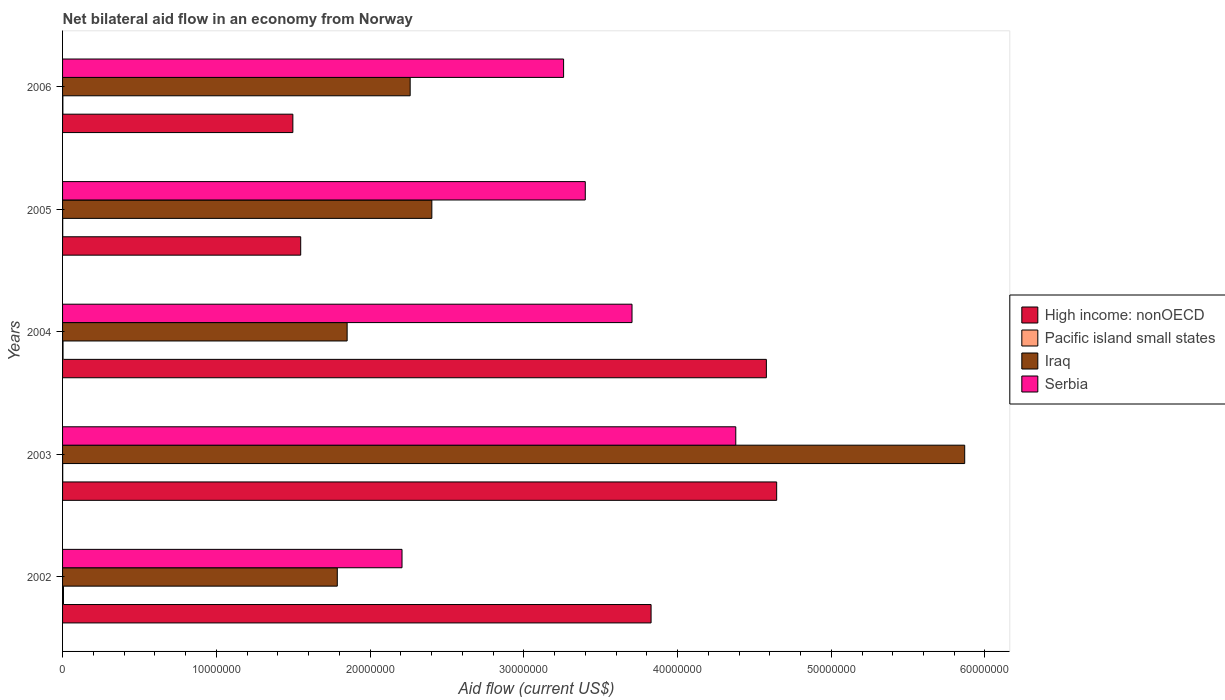How many different coloured bars are there?
Offer a terse response. 4. Are the number of bars per tick equal to the number of legend labels?
Your answer should be very brief. Yes. Are the number of bars on each tick of the Y-axis equal?
Keep it short and to the point. Yes. In how many cases, is the number of bars for a given year not equal to the number of legend labels?
Your answer should be compact. 0. What is the net bilateral aid flow in Serbia in 2002?
Give a very brief answer. 2.21e+07. Across all years, what is the maximum net bilateral aid flow in Pacific island small states?
Provide a succinct answer. 6.00e+04. Across all years, what is the minimum net bilateral aid flow in High income: nonOECD?
Your answer should be very brief. 1.50e+07. In which year was the net bilateral aid flow in High income: nonOECD maximum?
Provide a short and direct response. 2003. What is the total net bilateral aid flow in Serbia in the graph?
Ensure brevity in your answer.  1.70e+08. What is the difference between the net bilateral aid flow in Serbia in 2006 and the net bilateral aid flow in Pacific island small states in 2002?
Your answer should be very brief. 3.25e+07. What is the average net bilateral aid flow in Serbia per year?
Provide a succinct answer. 3.39e+07. In the year 2006, what is the difference between the net bilateral aid flow in High income: nonOECD and net bilateral aid flow in Serbia?
Your answer should be compact. -1.76e+07. What is the ratio of the net bilateral aid flow in High income: nonOECD in 2002 to that in 2003?
Your answer should be compact. 0.82. Is the difference between the net bilateral aid flow in High income: nonOECD in 2005 and 2006 greater than the difference between the net bilateral aid flow in Serbia in 2005 and 2006?
Offer a terse response. No. What is the difference between the highest and the second highest net bilateral aid flow in Iraq?
Keep it short and to the point. 3.47e+07. What is the difference between the highest and the lowest net bilateral aid flow in Iraq?
Offer a very short reply. 4.08e+07. What does the 1st bar from the top in 2003 represents?
Your answer should be compact. Serbia. What does the 3rd bar from the bottom in 2006 represents?
Your answer should be compact. Iraq. How many bars are there?
Provide a short and direct response. 20. Are all the bars in the graph horizontal?
Keep it short and to the point. Yes. What is the difference between two consecutive major ticks on the X-axis?
Your answer should be compact. 1.00e+07. Does the graph contain grids?
Your answer should be compact. No. How many legend labels are there?
Keep it short and to the point. 4. What is the title of the graph?
Your response must be concise. Net bilateral aid flow in an economy from Norway. What is the Aid flow (current US$) of High income: nonOECD in 2002?
Offer a terse response. 3.83e+07. What is the Aid flow (current US$) in Pacific island small states in 2002?
Provide a short and direct response. 6.00e+04. What is the Aid flow (current US$) of Iraq in 2002?
Make the answer very short. 1.79e+07. What is the Aid flow (current US$) in Serbia in 2002?
Keep it short and to the point. 2.21e+07. What is the Aid flow (current US$) in High income: nonOECD in 2003?
Provide a short and direct response. 4.64e+07. What is the Aid flow (current US$) of Pacific island small states in 2003?
Offer a terse response. 10000. What is the Aid flow (current US$) in Iraq in 2003?
Provide a succinct answer. 5.87e+07. What is the Aid flow (current US$) in Serbia in 2003?
Your response must be concise. 4.38e+07. What is the Aid flow (current US$) of High income: nonOECD in 2004?
Provide a succinct answer. 4.58e+07. What is the Aid flow (current US$) of Pacific island small states in 2004?
Make the answer very short. 3.00e+04. What is the Aid flow (current US$) in Iraq in 2004?
Offer a terse response. 1.85e+07. What is the Aid flow (current US$) in Serbia in 2004?
Keep it short and to the point. 3.70e+07. What is the Aid flow (current US$) of High income: nonOECD in 2005?
Make the answer very short. 1.55e+07. What is the Aid flow (current US$) in Pacific island small states in 2005?
Your response must be concise. 10000. What is the Aid flow (current US$) in Iraq in 2005?
Offer a terse response. 2.40e+07. What is the Aid flow (current US$) in Serbia in 2005?
Your response must be concise. 3.40e+07. What is the Aid flow (current US$) in High income: nonOECD in 2006?
Give a very brief answer. 1.50e+07. What is the Aid flow (current US$) of Pacific island small states in 2006?
Ensure brevity in your answer.  2.00e+04. What is the Aid flow (current US$) in Iraq in 2006?
Keep it short and to the point. 2.26e+07. What is the Aid flow (current US$) in Serbia in 2006?
Make the answer very short. 3.26e+07. Across all years, what is the maximum Aid flow (current US$) of High income: nonOECD?
Give a very brief answer. 4.64e+07. Across all years, what is the maximum Aid flow (current US$) of Pacific island small states?
Your answer should be very brief. 6.00e+04. Across all years, what is the maximum Aid flow (current US$) in Iraq?
Your answer should be compact. 5.87e+07. Across all years, what is the maximum Aid flow (current US$) in Serbia?
Give a very brief answer. 4.38e+07. Across all years, what is the minimum Aid flow (current US$) in High income: nonOECD?
Provide a succinct answer. 1.50e+07. Across all years, what is the minimum Aid flow (current US$) in Iraq?
Ensure brevity in your answer.  1.79e+07. Across all years, what is the minimum Aid flow (current US$) of Serbia?
Ensure brevity in your answer.  2.21e+07. What is the total Aid flow (current US$) of High income: nonOECD in the graph?
Keep it short and to the point. 1.61e+08. What is the total Aid flow (current US$) of Pacific island small states in the graph?
Ensure brevity in your answer.  1.30e+05. What is the total Aid flow (current US$) in Iraq in the graph?
Keep it short and to the point. 1.42e+08. What is the total Aid flow (current US$) in Serbia in the graph?
Ensure brevity in your answer.  1.70e+08. What is the difference between the Aid flow (current US$) in High income: nonOECD in 2002 and that in 2003?
Provide a succinct answer. -8.17e+06. What is the difference between the Aid flow (current US$) of Pacific island small states in 2002 and that in 2003?
Keep it short and to the point. 5.00e+04. What is the difference between the Aid flow (current US$) in Iraq in 2002 and that in 2003?
Your response must be concise. -4.08e+07. What is the difference between the Aid flow (current US$) in Serbia in 2002 and that in 2003?
Ensure brevity in your answer.  -2.17e+07. What is the difference between the Aid flow (current US$) in High income: nonOECD in 2002 and that in 2004?
Give a very brief answer. -7.50e+06. What is the difference between the Aid flow (current US$) in Iraq in 2002 and that in 2004?
Provide a succinct answer. -6.40e+05. What is the difference between the Aid flow (current US$) in Serbia in 2002 and that in 2004?
Your answer should be compact. -1.50e+07. What is the difference between the Aid flow (current US$) in High income: nonOECD in 2002 and that in 2005?
Your answer should be very brief. 2.28e+07. What is the difference between the Aid flow (current US$) in Iraq in 2002 and that in 2005?
Your answer should be compact. -6.15e+06. What is the difference between the Aid flow (current US$) of Serbia in 2002 and that in 2005?
Make the answer very short. -1.19e+07. What is the difference between the Aid flow (current US$) in High income: nonOECD in 2002 and that in 2006?
Keep it short and to the point. 2.33e+07. What is the difference between the Aid flow (current US$) in Iraq in 2002 and that in 2006?
Your answer should be very brief. -4.74e+06. What is the difference between the Aid flow (current US$) of Serbia in 2002 and that in 2006?
Your answer should be very brief. -1.05e+07. What is the difference between the Aid flow (current US$) of High income: nonOECD in 2003 and that in 2004?
Provide a short and direct response. 6.70e+05. What is the difference between the Aid flow (current US$) in Iraq in 2003 and that in 2004?
Offer a very short reply. 4.02e+07. What is the difference between the Aid flow (current US$) in Serbia in 2003 and that in 2004?
Provide a short and direct response. 6.75e+06. What is the difference between the Aid flow (current US$) in High income: nonOECD in 2003 and that in 2005?
Your response must be concise. 3.10e+07. What is the difference between the Aid flow (current US$) in Iraq in 2003 and that in 2005?
Provide a short and direct response. 3.47e+07. What is the difference between the Aid flow (current US$) of Serbia in 2003 and that in 2005?
Provide a short and direct response. 9.79e+06. What is the difference between the Aid flow (current US$) in High income: nonOECD in 2003 and that in 2006?
Make the answer very short. 3.15e+07. What is the difference between the Aid flow (current US$) of Pacific island small states in 2003 and that in 2006?
Make the answer very short. -10000. What is the difference between the Aid flow (current US$) of Iraq in 2003 and that in 2006?
Make the answer very short. 3.61e+07. What is the difference between the Aid flow (current US$) of Serbia in 2003 and that in 2006?
Your answer should be compact. 1.12e+07. What is the difference between the Aid flow (current US$) of High income: nonOECD in 2004 and that in 2005?
Your answer should be very brief. 3.03e+07. What is the difference between the Aid flow (current US$) of Pacific island small states in 2004 and that in 2005?
Your answer should be very brief. 2.00e+04. What is the difference between the Aid flow (current US$) in Iraq in 2004 and that in 2005?
Your response must be concise. -5.51e+06. What is the difference between the Aid flow (current US$) of Serbia in 2004 and that in 2005?
Keep it short and to the point. 3.04e+06. What is the difference between the Aid flow (current US$) in High income: nonOECD in 2004 and that in 2006?
Your response must be concise. 3.08e+07. What is the difference between the Aid flow (current US$) in Iraq in 2004 and that in 2006?
Your response must be concise. -4.10e+06. What is the difference between the Aid flow (current US$) in Serbia in 2004 and that in 2006?
Your response must be concise. 4.45e+06. What is the difference between the Aid flow (current US$) in High income: nonOECD in 2005 and that in 2006?
Ensure brevity in your answer.  5.10e+05. What is the difference between the Aid flow (current US$) of Pacific island small states in 2005 and that in 2006?
Your answer should be compact. -10000. What is the difference between the Aid flow (current US$) in Iraq in 2005 and that in 2006?
Provide a succinct answer. 1.41e+06. What is the difference between the Aid flow (current US$) of Serbia in 2005 and that in 2006?
Your answer should be compact. 1.41e+06. What is the difference between the Aid flow (current US$) of High income: nonOECD in 2002 and the Aid flow (current US$) of Pacific island small states in 2003?
Ensure brevity in your answer.  3.83e+07. What is the difference between the Aid flow (current US$) of High income: nonOECD in 2002 and the Aid flow (current US$) of Iraq in 2003?
Your answer should be very brief. -2.04e+07. What is the difference between the Aid flow (current US$) in High income: nonOECD in 2002 and the Aid flow (current US$) in Serbia in 2003?
Your answer should be very brief. -5.51e+06. What is the difference between the Aid flow (current US$) of Pacific island small states in 2002 and the Aid flow (current US$) of Iraq in 2003?
Provide a succinct answer. -5.86e+07. What is the difference between the Aid flow (current US$) in Pacific island small states in 2002 and the Aid flow (current US$) in Serbia in 2003?
Give a very brief answer. -4.37e+07. What is the difference between the Aid flow (current US$) of Iraq in 2002 and the Aid flow (current US$) of Serbia in 2003?
Ensure brevity in your answer.  -2.59e+07. What is the difference between the Aid flow (current US$) of High income: nonOECD in 2002 and the Aid flow (current US$) of Pacific island small states in 2004?
Keep it short and to the point. 3.82e+07. What is the difference between the Aid flow (current US$) of High income: nonOECD in 2002 and the Aid flow (current US$) of Iraq in 2004?
Your response must be concise. 1.98e+07. What is the difference between the Aid flow (current US$) of High income: nonOECD in 2002 and the Aid flow (current US$) of Serbia in 2004?
Offer a very short reply. 1.24e+06. What is the difference between the Aid flow (current US$) in Pacific island small states in 2002 and the Aid flow (current US$) in Iraq in 2004?
Offer a terse response. -1.84e+07. What is the difference between the Aid flow (current US$) in Pacific island small states in 2002 and the Aid flow (current US$) in Serbia in 2004?
Provide a short and direct response. -3.70e+07. What is the difference between the Aid flow (current US$) of Iraq in 2002 and the Aid flow (current US$) of Serbia in 2004?
Ensure brevity in your answer.  -1.92e+07. What is the difference between the Aid flow (current US$) in High income: nonOECD in 2002 and the Aid flow (current US$) in Pacific island small states in 2005?
Make the answer very short. 3.83e+07. What is the difference between the Aid flow (current US$) in High income: nonOECD in 2002 and the Aid flow (current US$) in Iraq in 2005?
Offer a terse response. 1.43e+07. What is the difference between the Aid flow (current US$) of High income: nonOECD in 2002 and the Aid flow (current US$) of Serbia in 2005?
Your answer should be compact. 4.28e+06. What is the difference between the Aid flow (current US$) of Pacific island small states in 2002 and the Aid flow (current US$) of Iraq in 2005?
Offer a very short reply. -2.40e+07. What is the difference between the Aid flow (current US$) of Pacific island small states in 2002 and the Aid flow (current US$) of Serbia in 2005?
Give a very brief answer. -3.39e+07. What is the difference between the Aid flow (current US$) of Iraq in 2002 and the Aid flow (current US$) of Serbia in 2005?
Keep it short and to the point. -1.61e+07. What is the difference between the Aid flow (current US$) of High income: nonOECD in 2002 and the Aid flow (current US$) of Pacific island small states in 2006?
Your response must be concise. 3.83e+07. What is the difference between the Aid flow (current US$) of High income: nonOECD in 2002 and the Aid flow (current US$) of Iraq in 2006?
Keep it short and to the point. 1.57e+07. What is the difference between the Aid flow (current US$) in High income: nonOECD in 2002 and the Aid flow (current US$) in Serbia in 2006?
Your response must be concise. 5.69e+06. What is the difference between the Aid flow (current US$) in Pacific island small states in 2002 and the Aid flow (current US$) in Iraq in 2006?
Keep it short and to the point. -2.26e+07. What is the difference between the Aid flow (current US$) of Pacific island small states in 2002 and the Aid flow (current US$) of Serbia in 2006?
Provide a short and direct response. -3.25e+07. What is the difference between the Aid flow (current US$) in Iraq in 2002 and the Aid flow (current US$) in Serbia in 2006?
Offer a terse response. -1.47e+07. What is the difference between the Aid flow (current US$) in High income: nonOECD in 2003 and the Aid flow (current US$) in Pacific island small states in 2004?
Provide a succinct answer. 4.64e+07. What is the difference between the Aid flow (current US$) in High income: nonOECD in 2003 and the Aid flow (current US$) in Iraq in 2004?
Provide a short and direct response. 2.79e+07. What is the difference between the Aid flow (current US$) in High income: nonOECD in 2003 and the Aid flow (current US$) in Serbia in 2004?
Your answer should be compact. 9.41e+06. What is the difference between the Aid flow (current US$) of Pacific island small states in 2003 and the Aid flow (current US$) of Iraq in 2004?
Make the answer very short. -1.85e+07. What is the difference between the Aid flow (current US$) in Pacific island small states in 2003 and the Aid flow (current US$) in Serbia in 2004?
Ensure brevity in your answer.  -3.70e+07. What is the difference between the Aid flow (current US$) of Iraq in 2003 and the Aid flow (current US$) of Serbia in 2004?
Offer a very short reply. 2.16e+07. What is the difference between the Aid flow (current US$) of High income: nonOECD in 2003 and the Aid flow (current US$) of Pacific island small states in 2005?
Ensure brevity in your answer.  4.64e+07. What is the difference between the Aid flow (current US$) in High income: nonOECD in 2003 and the Aid flow (current US$) in Iraq in 2005?
Provide a short and direct response. 2.24e+07. What is the difference between the Aid flow (current US$) of High income: nonOECD in 2003 and the Aid flow (current US$) of Serbia in 2005?
Your answer should be very brief. 1.24e+07. What is the difference between the Aid flow (current US$) of Pacific island small states in 2003 and the Aid flow (current US$) of Iraq in 2005?
Give a very brief answer. -2.40e+07. What is the difference between the Aid flow (current US$) in Pacific island small states in 2003 and the Aid flow (current US$) in Serbia in 2005?
Make the answer very short. -3.40e+07. What is the difference between the Aid flow (current US$) of Iraq in 2003 and the Aid flow (current US$) of Serbia in 2005?
Ensure brevity in your answer.  2.47e+07. What is the difference between the Aid flow (current US$) in High income: nonOECD in 2003 and the Aid flow (current US$) in Pacific island small states in 2006?
Provide a succinct answer. 4.64e+07. What is the difference between the Aid flow (current US$) of High income: nonOECD in 2003 and the Aid flow (current US$) of Iraq in 2006?
Offer a very short reply. 2.38e+07. What is the difference between the Aid flow (current US$) in High income: nonOECD in 2003 and the Aid flow (current US$) in Serbia in 2006?
Give a very brief answer. 1.39e+07. What is the difference between the Aid flow (current US$) of Pacific island small states in 2003 and the Aid flow (current US$) of Iraq in 2006?
Your answer should be very brief. -2.26e+07. What is the difference between the Aid flow (current US$) in Pacific island small states in 2003 and the Aid flow (current US$) in Serbia in 2006?
Ensure brevity in your answer.  -3.26e+07. What is the difference between the Aid flow (current US$) in Iraq in 2003 and the Aid flow (current US$) in Serbia in 2006?
Give a very brief answer. 2.61e+07. What is the difference between the Aid flow (current US$) in High income: nonOECD in 2004 and the Aid flow (current US$) in Pacific island small states in 2005?
Your response must be concise. 4.58e+07. What is the difference between the Aid flow (current US$) in High income: nonOECD in 2004 and the Aid flow (current US$) in Iraq in 2005?
Ensure brevity in your answer.  2.18e+07. What is the difference between the Aid flow (current US$) of High income: nonOECD in 2004 and the Aid flow (current US$) of Serbia in 2005?
Ensure brevity in your answer.  1.18e+07. What is the difference between the Aid flow (current US$) in Pacific island small states in 2004 and the Aid flow (current US$) in Iraq in 2005?
Make the answer very short. -2.40e+07. What is the difference between the Aid flow (current US$) of Pacific island small states in 2004 and the Aid flow (current US$) of Serbia in 2005?
Provide a short and direct response. -3.40e+07. What is the difference between the Aid flow (current US$) in Iraq in 2004 and the Aid flow (current US$) in Serbia in 2005?
Ensure brevity in your answer.  -1.55e+07. What is the difference between the Aid flow (current US$) of High income: nonOECD in 2004 and the Aid flow (current US$) of Pacific island small states in 2006?
Provide a succinct answer. 4.58e+07. What is the difference between the Aid flow (current US$) of High income: nonOECD in 2004 and the Aid flow (current US$) of Iraq in 2006?
Offer a terse response. 2.32e+07. What is the difference between the Aid flow (current US$) in High income: nonOECD in 2004 and the Aid flow (current US$) in Serbia in 2006?
Your response must be concise. 1.32e+07. What is the difference between the Aid flow (current US$) in Pacific island small states in 2004 and the Aid flow (current US$) in Iraq in 2006?
Provide a short and direct response. -2.26e+07. What is the difference between the Aid flow (current US$) in Pacific island small states in 2004 and the Aid flow (current US$) in Serbia in 2006?
Your response must be concise. -3.26e+07. What is the difference between the Aid flow (current US$) in Iraq in 2004 and the Aid flow (current US$) in Serbia in 2006?
Offer a terse response. -1.41e+07. What is the difference between the Aid flow (current US$) in High income: nonOECD in 2005 and the Aid flow (current US$) in Pacific island small states in 2006?
Make the answer very short. 1.55e+07. What is the difference between the Aid flow (current US$) in High income: nonOECD in 2005 and the Aid flow (current US$) in Iraq in 2006?
Your answer should be compact. -7.12e+06. What is the difference between the Aid flow (current US$) of High income: nonOECD in 2005 and the Aid flow (current US$) of Serbia in 2006?
Offer a terse response. -1.71e+07. What is the difference between the Aid flow (current US$) of Pacific island small states in 2005 and the Aid flow (current US$) of Iraq in 2006?
Keep it short and to the point. -2.26e+07. What is the difference between the Aid flow (current US$) of Pacific island small states in 2005 and the Aid flow (current US$) of Serbia in 2006?
Ensure brevity in your answer.  -3.26e+07. What is the difference between the Aid flow (current US$) in Iraq in 2005 and the Aid flow (current US$) in Serbia in 2006?
Ensure brevity in your answer.  -8.57e+06. What is the average Aid flow (current US$) in High income: nonOECD per year?
Provide a short and direct response. 3.22e+07. What is the average Aid flow (current US$) of Pacific island small states per year?
Your answer should be very brief. 2.60e+04. What is the average Aid flow (current US$) of Iraq per year?
Provide a short and direct response. 2.83e+07. What is the average Aid flow (current US$) in Serbia per year?
Your answer should be compact. 3.39e+07. In the year 2002, what is the difference between the Aid flow (current US$) in High income: nonOECD and Aid flow (current US$) in Pacific island small states?
Provide a succinct answer. 3.82e+07. In the year 2002, what is the difference between the Aid flow (current US$) in High income: nonOECD and Aid flow (current US$) in Iraq?
Provide a short and direct response. 2.04e+07. In the year 2002, what is the difference between the Aid flow (current US$) in High income: nonOECD and Aid flow (current US$) in Serbia?
Your answer should be very brief. 1.62e+07. In the year 2002, what is the difference between the Aid flow (current US$) of Pacific island small states and Aid flow (current US$) of Iraq?
Your response must be concise. -1.78e+07. In the year 2002, what is the difference between the Aid flow (current US$) of Pacific island small states and Aid flow (current US$) of Serbia?
Make the answer very short. -2.20e+07. In the year 2002, what is the difference between the Aid flow (current US$) of Iraq and Aid flow (current US$) of Serbia?
Offer a terse response. -4.21e+06. In the year 2003, what is the difference between the Aid flow (current US$) in High income: nonOECD and Aid flow (current US$) in Pacific island small states?
Offer a terse response. 4.64e+07. In the year 2003, what is the difference between the Aid flow (current US$) in High income: nonOECD and Aid flow (current US$) in Iraq?
Ensure brevity in your answer.  -1.22e+07. In the year 2003, what is the difference between the Aid flow (current US$) in High income: nonOECD and Aid flow (current US$) in Serbia?
Your response must be concise. 2.66e+06. In the year 2003, what is the difference between the Aid flow (current US$) in Pacific island small states and Aid flow (current US$) in Iraq?
Your answer should be very brief. -5.87e+07. In the year 2003, what is the difference between the Aid flow (current US$) of Pacific island small states and Aid flow (current US$) of Serbia?
Give a very brief answer. -4.38e+07. In the year 2003, what is the difference between the Aid flow (current US$) of Iraq and Aid flow (current US$) of Serbia?
Provide a short and direct response. 1.49e+07. In the year 2004, what is the difference between the Aid flow (current US$) in High income: nonOECD and Aid flow (current US$) in Pacific island small states?
Provide a short and direct response. 4.58e+07. In the year 2004, what is the difference between the Aid flow (current US$) in High income: nonOECD and Aid flow (current US$) in Iraq?
Provide a short and direct response. 2.73e+07. In the year 2004, what is the difference between the Aid flow (current US$) of High income: nonOECD and Aid flow (current US$) of Serbia?
Your answer should be very brief. 8.74e+06. In the year 2004, what is the difference between the Aid flow (current US$) of Pacific island small states and Aid flow (current US$) of Iraq?
Your response must be concise. -1.85e+07. In the year 2004, what is the difference between the Aid flow (current US$) of Pacific island small states and Aid flow (current US$) of Serbia?
Offer a terse response. -3.70e+07. In the year 2004, what is the difference between the Aid flow (current US$) in Iraq and Aid flow (current US$) in Serbia?
Your answer should be compact. -1.85e+07. In the year 2005, what is the difference between the Aid flow (current US$) of High income: nonOECD and Aid flow (current US$) of Pacific island small states?
Your answer should be very brief. 1.55e+07. In the year 2005, what is the difference between the Aid flow (current US$) in High income: nonOECD and Aid flow (current US$) in Iraq?
Provide a short and direct response. -8.53e+06. In the year 2005, what is the difference between the Aid flow (current US$) of High income: nonOECD and Aid flow (current US$) of Serbia?
Offer a terse response. -1.85e+07. In the year 2005, what is the difference between the Aid flow (current US$) in Pacific island small states and Aid flow (current US$) in Iraq?
Provide a short and direct response. -2.40e+07. In the year 2005, what is the difference between the Aid flow (current US$) of Pacific island small states and Aid flow (current US$) of Serbia?
Provide a succinct answer. -3.40e+07. In the year 2005, what is the difference between the Aid flow (current US$) in Iraq and Aid flow (current US$) in Serbia?
Ensure brevity in your answer.  -9.98e+06. In the year 2006, what is the difference between the Aid flow (current US$) in High income: nonOECD and Aid flow (current US$) in Pacific island small states?
Provide a short and direct response. 1.50e+07. In the year 2006, what is the difference between the Aid flow (current US$) of High income: nonOECD and Aid flow (current US$) of Iraq?
Your response must be concise. -7.63e+06. In the year 2006, what is the difference between the Aid flow (current US$) in High income: nonOECD and Aid flow (current US$) in Serbia?
Offer a terse response. -1.76e+07. In the year 2006, what is the difference between the Aid flow (current US$) in Pacific island small states and Aid flow (current US$) in Iraq?
Provide a succinct answer. -2.26e+07. In the year 2006, what is the difference between the Aid flow (current US$) of Pacific island small states and Aid flow (current US$) of Serbia?
Your answer should be very brief. -3.26e+07. In the year 2006, what is the difference between the Aid flow (current US$) in Iraq and Aid flow (current US$) in Serbia?
Give a very brief answer. -9.98e+06. What is the ratio of the Aid flow (current US$) of High income: nonOECD in 2002 to that in 2003?
Offer a very short reply. 0.82. What is the ratio of the Aid flow (current US$) of Pacific island small states in 2002 to that in 2003?
Provide a succinct answer. 6. What is the ratio of the Aid flow (current US$) of Iraq in 2002 to that in 2003?
Ensure brevity in your answer.  0.3. What is the ratio of the Aid flow (current US$) in Serbia in 2002 to that in 2003?
Provide a short and direct response. 0.5. What is the ratio of the Aid flow (current US$) of High income: nonOECD in 2002 to that in 2004?
Your response must be concise. 0.84. What is the ratio of the Aid flow (current US$) of Iraq in 2002 to that in 2004?
Offer a very short reply. 0.97. What is the ratio of the Aid flow (current US$) in Serbia in 2002 to that in 2004?
Your response must be concise. 0.6. What is the ratio of the Aid flow (current US$) in High income: nonOECD in 2002 to that in 2005?
Offer a terse response. 2.47. What is the ratio of the Aid flow (current US$) of Pacific island small states in 2002 to that in 2005?
Keep it short and to the point. 6. What is the ratio of the Aid flow (current US$) in Iraq in 2002 to that in 2005?
Give a very brief answer. 0.74. What is the ratio of the Aid flow (current US$) of Serbia in 2002 to that in 2005?
Give a very brief answer. 0.65. What is the ratio of the Aid flow (current US$) of High income: nonOECD in 2002 to that in 2006?
Offer a very short reply. 2.56. What is the ratio of the Aid flow (current US$) in Pacific island small states in 2002 to that in 2006?
Give a very brief answer. 3. What is the ratio of the Aid flow (current US$) in Iraq in 2002 to that in 2006?
Keep it short and to the point. 0.79. What is the ratio of the Aid flow (current US$) of Serbia in 2002 to that in 2006?
Keep it short and to the point. 0.68. What is the ratio of the Aid flow (current US$) in High income: nonOECD in 2003 to that in 2004?
Provide a succinct answer. 1.01. What is the ratio of the Aid flow (current US$) in Iraq in 2003 to that in 2004?
Make the answer very short. 3.17. What is the ratio of the Aid flow (current US$) in Serbia in 2003 to that in 2004?
Give a very brief answer. 1.18. What is the ratio of the Aid flow (current US$) in High income: nonOECD in 2003 to that in 2005?
Make the answer very short. 3. What is the ratio of the Aid flow (current US$) in Iraq in 2003 to that in 2005?
Your answer should be compact. 2.44. What is the ratio of the Aid flow (current US$) in Serbia in 2003 to that in 2005?
Ensure brevity in your answer.  1.29. What is the ratio of the Aid flow (current US$) in High income: nonOECD in 2003 to that in 2006?
Make the answer very short. 3.1. What is the ratio of the Aid flow (current US$) in Pacific island small states in 2003 to that in 2006?
Offer a very short reply. 0.5. What is the ratio of the Aid flow (current US$) of Iraq in 2003 to that in 2006?
Keep it short and to the point. 2.6. What is the ratio of the Aid flow (current US$) of Serbia in 2003 to that in 2006?
Your response must be concise. 1.34. What is the ratio of the Aid flow (current US$) in High income: nonOECD in 2004 to that in 2005?
Make the answer very short. 2.96. What is the ratio of the Aid flow (current US$) of Iraq in 2004 to that in 2005?
Provide a succinct answer. 0.77. What is the ratio of the Aid flow (current US$) in Serbia in 2004 to that in 2005?
Keep it short and to the point. 1.09. What is the ratio of the Aid flow (current US$) of High income: nonOECD in 2004 to that in 2006?
Provide a succinct answer. 3.06. What is the ratio of the Aid flow (current US$) in Iraq in 2004 to that in 2006?
Ensure brevity in your answer.  0.82. What is the ratio of the Aid flow (current US$) of Serbia in 2004 to that in 2006?
Give a very brief answer. 1.14. What is the ratio of the Aid flow (current US$) of High income: nonOECD in 2005 to that in 2006?
Your answer should be very brief. 1.03. What is the ratio of the Aid flow (current US$) in Pacific island small states in 2005 to that in 2006?
Offer a terse response. 0.5. What is the ratio of the Aid flow (current US$) of Iraq in 2005 to that in 2006?
Provide a short and direct response. 1.06. What is the ratio of the Aid flow (current US$) of Serbia in 2005 to that in 2006?
Your response must be concise. 1.04. What is the difference between the highest and the second highest Aid flow (current US$) in High income: nonOECD?
Provide a succinct answer. 6.70e+05. What is the difference between the highest and the second highest Aid flow (current US$) in Pacific island small states?
Your answer should be very brief. 3.00e+04. What is the difference between the highest and the second highest Aid flow (current US$) in Iraq?
Your answer should be compact. 3.47e+07. What is the difference between the highest and the second highest Aid flow (current US$) in Serbia?
Give a very brief answer. 6.75e+06. What is the difference between the highest and the lowest Aid flow (current US$) of High income: nonOECD?
Offer a very short reply. 3.15e+07. What is the difference between the highest and the lowest Aid flow (current US$) in Iraq?
Ensure brevity in your answer.  4.08e+07. What is the difference between the highest and the lowest Aid flow (current US$) of Serbia?
Provide a short and direct response. 2.17e+07. 